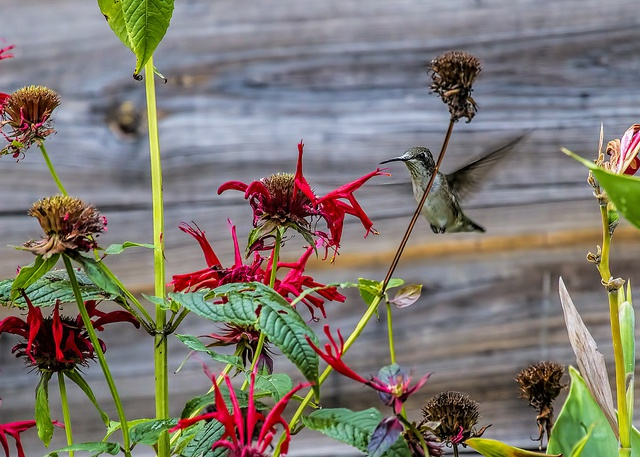Describe the objects in this image and their specific colors. I can see a bird in darkgray, gray, black, and darkgreen tones in this image. 